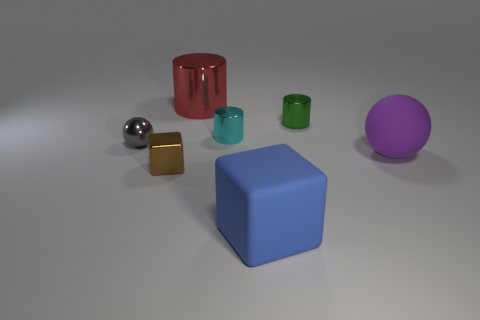How many things are small objects that are left of the big rubber block or small gray shiny cubes?
Your answer should be compact. 3. Does the large block have the same material as the cylinder behind the small green metal cylinder?
Provide a succinct answer. No. Are there any big green cylinders made of the same material as the tiny gray thing?
Your response must be concise. No. What number of objects are small metal things to the right of the large red cylinder or large objects that are in front of the purple thing?
Give a very brief answer. 3. There is a purple thing; is its shape the same as the metallic thing to the left of the small shiny block?
Offer a very short reply. Yes. How many other things are there of the same shape as the red thing?
Your answer should be compact. 2. How many objects are either large balls or brown shiny blocks?
Your answer should be compact. 2. Do the tiny shiny sphere and the big metal thing have the same color?
Make the answer very short. No. Is there anything else that is the same size as the blue object?
Your answer should be compact. Yes. There is a shiny object right of the blue block right of the small cyan thing; what shape is it?
Ensure brevity in your answer.  Cylinder. 